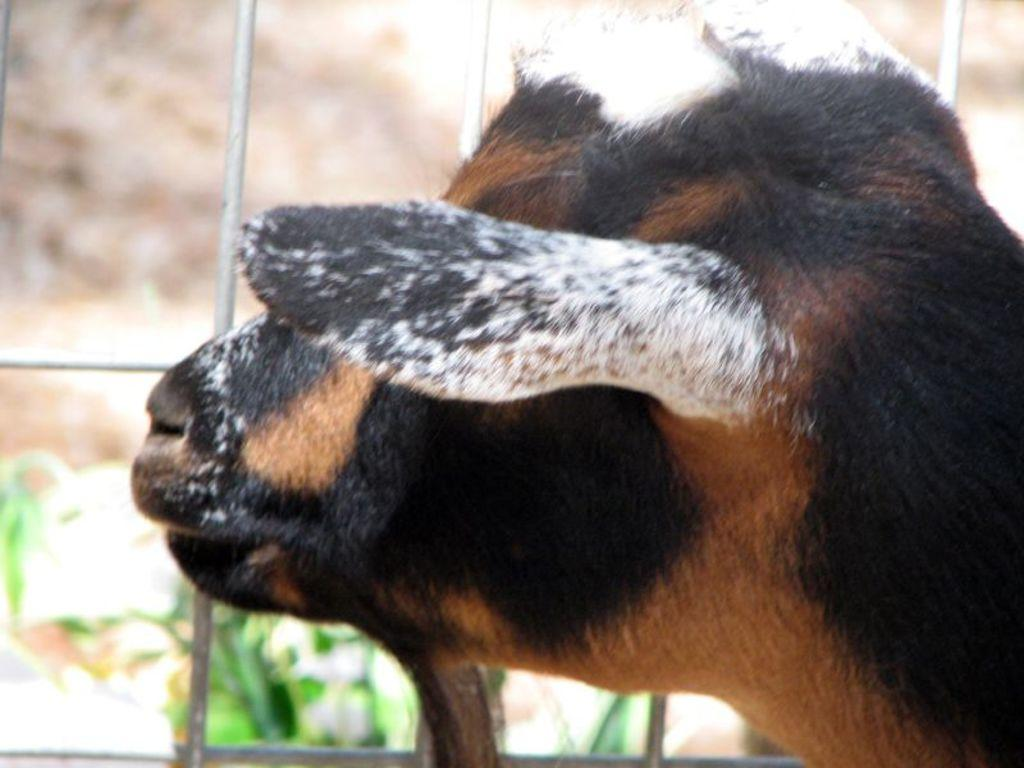What type of animal can be seen in the image? A: There is an animal in the image, but its specific type cannot be determined from the provided facts. What is the animal doing in the image? The animal is looking at the back side. What can be seen behind the animal in the image? There is a metal frame in the image. What is present in front of the metal frame? Leaves are visible in front of the metal frame. How would you describe the background of the image? The background of the image is blurred. What type of advertisement can be seen on the shop in the image? There is no shop or advertisement present in the image. What is the noise level in the image? The noise level cannot be determined from the image, as there is no information about sounds or audio in the provided facts. 